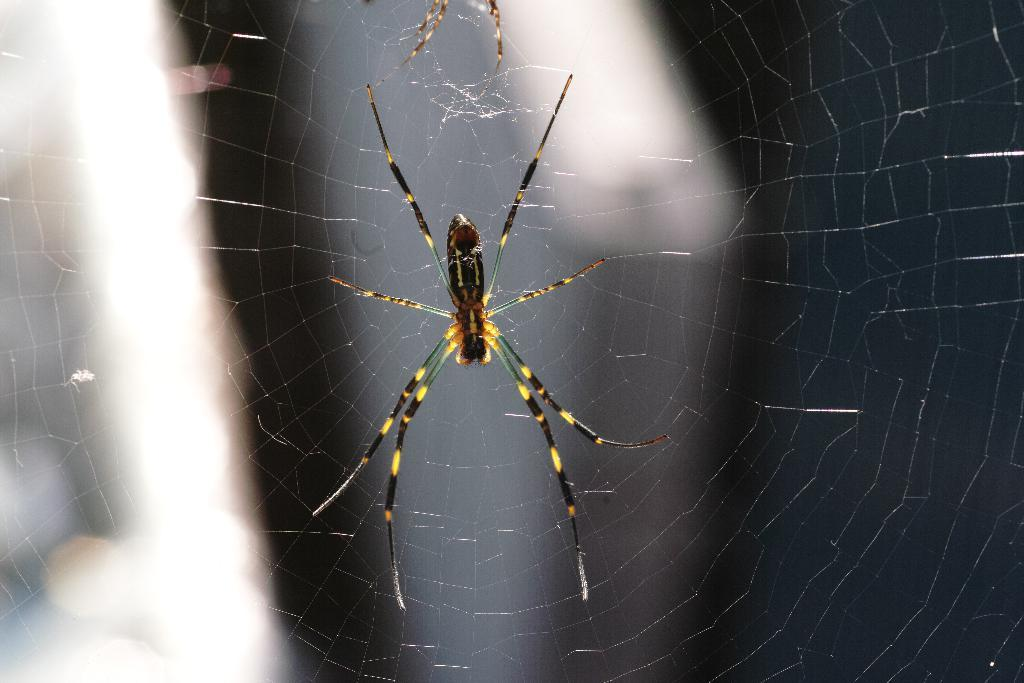What type of animal can be seen in the image? There is a spider in the image. What type of underwear is the spider wearing in the image? There is no underwear present in the image, as spiders do not wear clothing. 